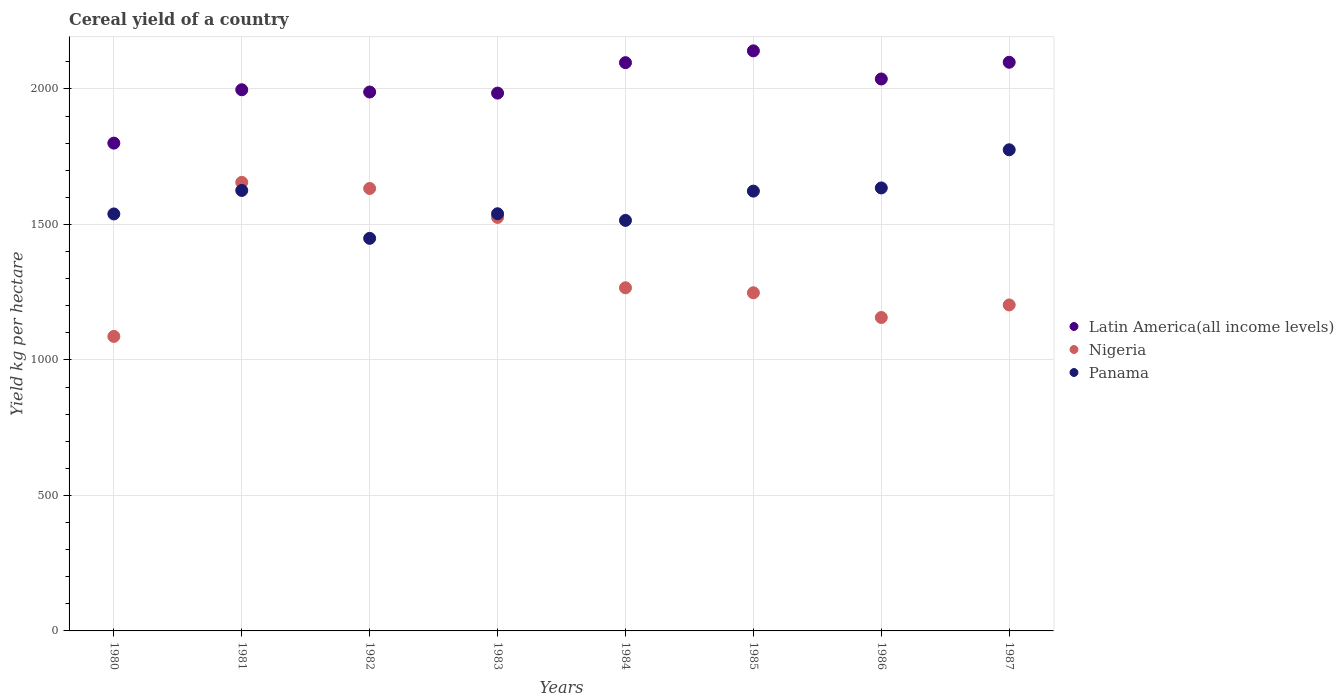Is the number of dotlines equal to the number of legend labels?
Ensure brevity in your answer.  Yes. What is the total cereal yield in Panama in 1983?
Your answer should be very brief. 1539.59. Across all years, what is the maximum total cereal yield in Nigeria?
Keep it short and to the point. 1655.46. Across all years, what is the minimum total cereal yield in Nigeria?
Ensure brevity in your answer.  1086.95. What is the total total cereal yield in Panama in the graph?
Provide a short and direct response. 1.27e+04. What is the difference between the total cereal yield in Latin America(all income levels) in 1982 and that in 1987?
Your answer should be compact. -109.78. What is the difference between the total cereal yield in Latin America(all income levels) in 1984 and the total cereal yield in Nigeria in 1985?
Offer a terse response. 849.26. What is the average total cereal yield in Panama per year?
Make the answer very short. 1587.7. In the year 1982, what is the difference between the total cereal yield in Latin America(all income levels) and total cereal yield in Nigeria?
Your response must be concise. 356. What is the ratio of the total cereal yield in Panama in 1983 to that in 1985?
Keep it short and to the point. 0.95. Is the difference between the total cereal yield in Latin America(all income levels) in 1983 and 1987 greater than the difference between the total cereal yield in Nigeria in 1983 and 1987?
Your response must be concise. No. What is the difference between the highest and the second highest total cereal yield in Panama?
Make the answer very short. 140.84. What is the difference between the highest and the lowest total cereal yield in Latin America(all income levels)?
Provide a short and direct response. 340.54. In how many years, is the total cereal yield in Panama greater than the average total cereal yield in Panama taken over all years?
Make the answer very short. 4. Is the sum of the total cereal yield in Nigeria in 1985 and 1987 greater than the maximum total cereal yield in Latin America(all income levels) across all years?
Ensure brevity in your answer.  Yes. Is it the case that in every year, the sum of the total cereal yield in Nigeria and total cereal yield in Latin America(all income levels)  is greater than the total cereal yield in Panama?
Your answer should be very brief. Yes. Is the total cereal yield in Panama strictly greater than the total cereal yield in Nigeria over the years?
Keep it short and to the point. No. Is the total cereal yield in Nigeria strictly less than the total cereal yield in Panama over the years?
Ensure brevity in your answer.  No. How many dotlines are there?
Offer a very short reply. 3. Where does the legend appear in the graph?
Give a very brief answer. Center right. How are the legend labels stacked?
Your response must be concise. Vertical. What is the title of the graph?
Ensure brevity in your answer.  Cereal yield of a country. What is the label or title of the Y-axis?
Offer a terse response. Yield kg per hectare. What is the Yield kg per hectare in Latin America(all income levels) in 1980?
Provide a short and direct response. 1800.24. What is the Yield kg per hectare in Nigeria in 1980?
Ensure brevity in your answer.  1086.95. What is the Yield kg per hectare in Panama in 1980?
Your answer should be compact. 1538.86. What is the Yield kg per hectare of Latin America(all income levels) in 1981?
Provide a succinct answer. 1997.19. What is the Yield kg per hectare in Nigeria in 1981?
Offer a terse response. 1655.46. What is the Yield kg per hectare in Panama in 1981?
Keep it short and to the point. 1625.58. What is the Yield kg per hectare in Latin America(all income levels) in 1982?
Offer a very short reply. 1988.86. What is the Yield kg per hectare of Nigeria in 1982?
Your answer should be compact. 1632.86. What is the Yield kg per hectare in Panama in 1982?
Give a very brief answer. 1448.84. What is the Yield kg per hectare in Latin America(all income levels) in 1983?
Your answer should be compact. 1984.83. What is the Yield kg per hectare in Nigeria in 1983?
Provide a short and direct response. 1526.02. What is the Yield kg per hectare in Panama in 1983?
Your answer should be very brief. 1539.59. What is the Yield kg per hectare of Latin America(all income levels) in 1984?
Your response must be concise. 2097.18. What is the Yield kg per hectare of Nigeria in 1984?
Provide a short and direct response. 1266.34. What is the Yield kg per hectare of Panama in 1984?
Keep it short and to the point. 1515.07. What is the Yield kg per hectare of Latin America(all income levels) in 1985?
Your response must be concise. 2140.78. What is the Yield kg per hectare of Nigeria in 1985?
Ensure brevity in your answer.  1247.93. What is the Yield kg per hectare of Panama in 1985?
Provide a succinct answer. 1623.14. What is the Yield kg per hectare in Latin America(all income levels) in 1986?
Offer a terse response. 2036.96. What is the Yield kg per hectare of Nigeria in 1986?
Provide a short and direct response. 1156.71. What is the Yield kg per hectare of Panama in 1986?
Offer a terse response. 1634.85. What is the Yield kg per hectare in Latin America(all income levels) in 1987?
Provide a short and direct response. 2098.64. What is the Yield kg per hectare in Nigeria in 1987?
Provide a succinct answer. 1203.01. What is the Yield kg per hectare in Panama in 1987?
Offer a very short reply. 1775.69. Across all years, what is the maximum Yield kg per hectare of Latin America(all income levels)?
Give a very brief answer. 2140.78. Across all years, what is the maximum Yield kg per hectare in Nigeria?
Your answer should be very brief. 1655.46. Across all years, what is the maximum Yield kg per hectare in Panama?
Provide a succinct answer. 1775.69. Across all years, what is the minimum Yield kg per hectare in Latin America(all income levels)?
Give a very brief answer. 1800.24. Across all years, what is the minimum Yield kg per hectare in Nigeria?
Keep it short and to the point. 1086.95. Across all years, what is the minimum Yield kg per hectare in Panama?
Keep it short and to the point. 1448.84. What is the total Yield kg per hectare in Latin America(all income levels) in the graph?
Ensure brevity in your answer.  1.61e+04. What is the total Yield kg per hectare of Nigeria in the graph?
Keep it short and to the point. 1.08e+04. What is the total Yield kg per hectare of Panama in the graph?
Offer a terse response. 1.27e+04. What is the difference between the Yield kg per hectare of Latin America(all income levels) in 1980 and that in 1981?
Your answer should be compact. -196.95. What is the difference between the Yield kg per hectare of Nigeria in 1980 and that in 1981?
Make the answer very short. -568.51. What is the difference between the Yield kg per hectare in Panama in 1980 and that in 1981?
Make the answer very short. -86.72. What is the difference between the Yield kg per hectare in Latin America(all income levels) in 1980 and that in 1982?
Your answer should be compact. -188.62. What is the difference between the Yield kg per hectare of Nigeria in 1980 and that in 1982?
Provide a succinct answer. -545.91. What is the difference between the Yield kg per hectare of Panama in 1980 and that in 1982?
Ensure brevity in your answer.  90.03. What is the difference between the Yield kg per hectare in Latin America(all income levels) in 1980 and that in 1983?
Provide a short and direct response. -184.6. What is the difference between the Yield kg per hectare in Nigeria in 1980 and that in 1983?
Your response must be concise. -439.07. What is the difference between the Yield kg per hectare of Panama in 1980 and that in 1983?
Give a very brief answer. -0.73. What is the difference between the Yield kg per hectare in Latin America(all income levels) in 1980 and that in 1984?
Provide a short and direct response. -296.95. What is the difference between the Yield kg per hectare in Nigeria in 1980 and that in 1984?
Provide a succinct answer. -179.39. What is the difference between the Yield kg per hectare of Panama in 1980 and that in 1984?
Offer a very short reply. 23.79. What is the difference between the Yield kg per hectare in Latin America(all income levels) in 1980 and that in 1985?
Give a very brief answer. -340.54. What is the difference between the Yield kg per hectare in Nigeria in 1980 and that in 1985?
Your answer should be very brief. -160.98. What is the difference between the Yield kg per hectare in Panama in 1980 and that in 1985?
Your answer should be compact. -84.28. What is the difference between the Yield kg per hectare in Latin America(all income levels) in 1980 and that in 1986?
Make the answer very short. -236.73. What is the difference between the Yield kg per hectare in Nigeria in 1980 and that in 1986?
Ensure brevity in your answer.  -69.76. What is the difference between the Yield kg per hectare of Panama in 1980 and that in 1986?
Your answer should be compact. -95.98. What is the difference between the Yield kg per hectare of Latin America(all income levels) in 1980 and that in 1987?
Provide a short and direct response. -298.4. What is the difference between the Yield kg per hectare of Nigeria in 1980 and that in 1987?
Offer a terse response. -116.06. What is the difference between the Yield kg per hectare in Panama in 1980 and that in 1987?
Your response must be concise. -236.83. What is the difference between the Yield kg per hectare of Latin America(all income levels) in 1981 and that in 1982?
Your answer should be compact. 8.34. What is the difference between the Yield kg per hectare in Nigeria in 1981 and that in 1982?
Ensure brevity in your answer.  22.61. What is the difference between the Yield kg per hectare of Panama in 1981 and that in 1982?
Offer a very short reply. 176.74. What is the difference between the Yield kg per hectare of Latin America(all income levels) in 1981 and that in 1983?
Your answer should be very brief. 12.36. What is the difference between the Yield kg per hectare of Nigeria in 1981 and that in 1983?
Provide a succinct answer. 129.45. What is the difference between the Yield kg per hectare of Panama in 1981 and that in 1983?
Your answer should be very brief. 85.99. What is the difference between the Yield kg per hectare in Latin America(all income levels) in 1981 and that in 1984?
Your answer should be compact. -99.99. What is the difference between the Yield kg per hectare in Nigeria in 1981 and that in 1984?
Provide a succinct answer. 389.13. What is the difference between the Yield kg per hectare of Panama in 1981 and that in 1984?
Provide a succinct answer. 110.51. What is the difference between the Yield kg per hectare in Latin America(all income levels) in 1981 and that in 1985?
Offer a very short reply. -143.58. What is the difference between the Yield kg per hectare in Nigeria in 1981 and that in 1985?
Make the answer very short. 407.54. What is the difference between the Yield kg per hectare in Panama in 1981 and that in 1985?
Offer a very short reply. 2.44. What is the difference between the Yield kg per hectare in Latin America(all income levels) in 1981 and that in 1986?
Give a very brief answer. -39.77. What is the difference between the Yield kg per hectare of Nigeria in 1981 and that in 1986?
Ensure brevity in your answer.  498.75. What is the difference between the Yield kg per hectare of Panama in 1981 and that in 1986?
Give a very brief answer. -9.27. What is the difference between the Yield kg per hectare of Latin America(all income levels) in 1981 and that in 1987?
Offer a terse response. -101.44. What is the difference between the Yield kg per hectare in Nigeria in 1981 and that in 1987?
Keep it short and to the point. 452.45. What is the difference between the Yield kg per hectare of Panama in 1981 and that in 1987?
Offer a very short reply. -150.11. What is the difference between the Yield kg per hectare of Latin America(all income levels) in 1982 and that in 1983?
Offer a terse response. 4.02. What is the difference between the Yield kg per hectare in Nigeria in 1982 and that in 1983?
Provide a succinct answer. 106.84. What is the difference between the Yield kg per hectare of Panama in 1982 and that in 1983?
Your answer should be very brief. -90.76. What is the difference between the Yield kg per hectare of Latin America(all income levels) in 1982 and that in 1984?
Ensure brevity in your answer.  -108.33. What is the difference between the Yield kg per hectare in Nigeria in 1982 and that in 1984?
Make the answer very short. 366.52. What is the difference between the Yield kg per hectare in Panama in 1982 and that in 1984?
Ensure brevity in your answer.  -66.23. What is the difference between the Yield kg per hectare in Latin America(all income levels) in 1982 and that in 1985?
Your response must be concise. -151.92. What is the difference between the Yield kg per hectare of Nigeria in 1982 and that in 1985?
Your answer should be very brief. 384.93. What is the difference between the Yield kg per hectare of Panama in 1982 and that in 1985?
Offer a very short reply. -174.3. What is the difference between the Yield kg per hectare of Latin America(all income levels) in 1982 and that in 1986?
Offer a very short reply. -48.11. What is the difference between the Yield kg per hectare of Nigeria in 1982 and that in 1986?
Your answer should be very brief. 476.15. What is the difference between the Yield kg per hectare in Panama in 1982 and that in 1986?
Provide a short and direct response. -186.01. What is the difference between the Yield kg per hectare of Latin America(all income levels) in 1982 and that in 1987?
Ensure brevity in your answer.  -109.78. What is the difference between the Yield kg per hectare of Nigeria in 1982 and that in 1987?
Keep it short and to the point. 429.85. What is the difference between the Yield kg per hectare in Panama in 1982 and that in 1987?
Your response must be concise. -326.85. What is the difference between the Yield kg per hectare in Latin America(all income levels) in 1983 and that in 1984?
Provide a succinct answer. -112.35. What is the difference between the Yield kg per hectare of Nigeria in 1983 and that in 1984?
Your answer should be very brief. 259.68. What is the difference between the Yield kg per hectare in Panama in 1983 and that in 1984?
Make the answer very short. 24.52. What is the difference between the Yield kg per hectare of Latin America(all income levels) in 1983 and that in 1985?
Give a very brief answer. -155.94. What is the difference between the Yield kg per hectare of Nigeria in 1983 and that in 1985?
Make the answer very short. 278.09. What is the difference between the Yield kg per hectare of Panama in 1983 and that in 1985?
Your answer should be very brief. -83.55. What is the difference between the Yield kg per hectare in Latin America(all income levels) in 1983 and that in 1986?
Keep it short and to the point. -52.13. What is the difference between the Yield kg per hectare in Nigeria in 1983 and that in 1986?
Your answer should be very brief. 369.3. What is the difference between the Yield kg per hectare of Panama in 1983 and that in 1986?
Your answer should be very brief. -95.25. What is the difference between the Yield kg per hectare of Latin America(all income levels) in 1983 and that in 1987?
Provide a short and direct response. -113.8. What is the difference between the Yield kg per hectare of Nigeria in 1983 and that in 1987?
Provide a succinct answer. 323.01. What is the difference between the Yield kg per hectare in Panama in 1983 and that in 1987?
Offer a terse response. -236.09. What is the difference between the Yield kg per hectare of Latin America(all income levels) in 1984 and that in 1985?
Give a very brief answer. -43.59. What is the difference between the Yield kg per hectare in Nigeria in 1984 and that in 1985?
Give a very brief answer. 18.41. What is the difference between the Yield kg per hectare in Panama in 1984 and that in 1985?
Provide a succinct answer. -108.07. What is the difference between the Yield kg per hectare in Latin America(all income levels) in 1984 and that in 1986?
Your answer should be very brief. 60.22. What is the difference between the Yield kg per hectare of Nigeria in 1984 and that in 1986?
Your answer should be compact. 109.62. What is the difference between the Yield kg per hectare in Panama in 1984 and that in 1986?
Your answer should be very brief. -119.78. What is the difference between the Yield kg per hectare in Latin America(all income levels) in 1984 and that in 1987?
Your answer should be compact. -1.45. What is the difference between the Yield kg per hectare of Nigeria in 1984 and that in 1987?
Provide a succinct answer. 63.33. What is the difference between the Yield kg per hectare in Panama in 1984 and that in 1987?
Offer a very short reply. -260.62. What is the difference between the Yield kg per hectare of Latin America(all income levels) in 1985 and that in 1986?
Make the answer very short. 103.81. What is the difference between the Yield kg per hectare in Nigeria in 1985 and that in 1986?
Ensure brevity in your answer.  91.22. What is the difference between the Yield kg per hectare in Panama in 1985 and that in 1986?
Your response must be concise. -11.71. What is the difference between the Yield kg per hectare in Latin America(all income levels) in 1985 and that in 1987?
Keep it short and to the point. 42.14. What is the difference between the Yield kg per hectare of Nigeria in 1985 and that in 1987?
Your answer should be very brief. 44.92. What is the difference between the Yield kg per hectare of Panama in 1985 and that in 1987?
Provide a short and direct response. -152.55. What is the difference between the Yield kg per hectare in Latin America(all income levels) in 1986 and that in 1987?
Offer a terse response. -61.67. What is the difference between the Yield kg per hectare in Nigeria in 1986 and that in 1987?
Offer a terse response. -46.3. What is the difference between the Yield kg per hectare in Panama in 1986 and that in 1987?
Provide a short and direct response. -140.84. What is the difference between the Yield kg per hectare in Latin America(all income levels) in 1980 and the Yield kg per hectare in Nigeria in 1981?
Provide a short and direct response. 144.77. What is the difference between the Yield kg per hectare in Latin America(all income levels) in 1980 and the Yield kg per hectare in Panama in 1981?
Keep it short and to the point. 174.66. What is the difference between the Yield kg per hectare of Nigeria in 1980 and the Yield kg per hectare of Panama in 1981?
Your answer should be very brief. -538.63. What is the difference between the Yield kg per hectare in Latin America(all income levels) in 1980 and the Yield kg per hectare in Nigeria in 1982?
Provide a short and direct response. 167.38. What is the difference between the Yield kg per hectare of Latin America(all income levels) in 1980 and the Yield kg per hectare of Panama in 1982?
Offer a terse response. 351.4. What is the difference between the Yield kg per hectare of Nigeria in 1980 and the Yield kg per hectare of Panama in 1982?
Offer a very short reply. -361.88. What is the difference between the Yield kg per hectare in Latin America(all income levels) in 1980 and the Yield kg per hectare in Nigeria in 1983?
Your answer should be compact. 274.22. What is the difference between the Yield kg per hectare of Latin America(all income levels) in 1980 and the Yield kg per hectare of Panama in 1983?
Offer a very short reply. 260.64. What is the difference between the Yield kg per hectare in Nigeria in 1980 and the Yield kg per hectare in Panama in 1983?
Offer a terse response. -452.64. What is the difference between the Yield kg per hectare of Latin America(all income levels) in 1980 and the Yield kg per hectare of Nigeria in 1984?
Make the answer very short. 533.9. What is the difference between the Yield kg per hectare in Latin America(all income levels) in 1980 and the Yield kg per hectare in Panama in 1984?
Ensure brevity in your answer.  285.17. What is the difference between the Yield kg per hectare in Nigeria in 1980 and the Yield kg per hectare in Panama in 1984?
Keep it short and to the point. -428.12. What is the difference between the Yield kg per hectare in Latin America(all income levels) in 1980 and the Yield kg per hectare in Nigeria in 1985?
Ensure brevity in your answer.  552.31. What is the difference between the Yield kg per hectare in Latin America(all income levels) in 1980 and the Yield kg per hectare in Panama in 1985?
Your answer should be compact. 177.1. What is the difference between the Yield kg per hectare in Nigeria in 1980 and the Yield kg per hectare in Panama in 1985?
Provide a short and direct response. -536.19. What is the difference between the Yield kg per hectare in Latin America(all income levels) in 1980 and the Yield kg per hectare in Nigeria in 1986?
Offer a very short reply. 643.52. What is the difference between the Yield kg per hectare of Latin America(all income levels) in 1980 and the Yield kg per hectare of Panama in 1986?
Provide a short and direct response. 165.39. What is the difference between the Yield kg per hectare of Nigeria in 1980 and the Yield kg per hectare of Panama in 1986?
Give a very brief answer. -547.9. What is the difference between the Yield kg per hectare of Latin America(all income levels) in 1980 and the Yield kg per hectare of Nigeria in 1987?
Give a very brief answer. 597.23. What is the difference between the Yield kg per hectare in Latin America(all income levels) in 1980 and the Yield kg per hectare in Panama in 1987?
Your answer should be compact. 24.55. What is the difference between the Yield kg per hectare of Nigeria in 1980 and the Yield kg per hectare of Panama in 1987?
Provide a short and direct response. -688.74. What is the difference between the Yield kg per hectare in Latin America(all income levels) in 1981 and the Yield kg per hectare in Nigeria in 1982?
Provide a succinct answer. 364.33. What is the difference between the Yield kg per hectare of Latin America(all income levels) in 1981 and the Yield kg per hectare of Panama in 1982?
Your answer should be compact. 548.36. What is the difference between the Yield kg per hectare of Nigeria in 1981 and the Yield kg per hectare of Panama in 1982?
Keep it short and to the point. 206.63. What is the difference between the Yield kg per hectare in Latin America(all income levels) in 1981 and the Yield kg per hectare in Nigeria in 1983?
Your answer should be very brief. 471.18. What is the difference between the Yield kg per hectare of Latin America(all income levels) in 1981 and the Yield kg per hectare of Panama in 1983?
Your answer should be very brief. 457.6. What is the difference between the Yield kg per hectare of Nigeria in 1981 and the Yield kg per hectare of Panama in 1983?
Ensure brevity in your answer.  115.87. What is the difference between the Yield kg per hectare in Latin America(all income levels) in 1981 and the Yield kg per hectare in Nigeria in 1984?
Provide a succinct answer. 730.85. What is the difference between the Yield kg per hectare of Latin America(all income levels) in 1981 and the Yield kg per hectare of Panama in 1984?
Offer a very short reply. 482.12. What is the difference between the Yield kg per hectare in Nigeria in 1981 and the Yield kg per hectare in Panama in 1984?
Your answer should be very brief. 140.4. What is the difference between the Yield kg per hectare of Latin America(all income levels) in 1981 and the Yield kg per hectare of Nigeria in 1985?
Give a very brief answer. 749.26. What is the difference between the Yield kg per hectare of Latin America(all income levels) in 1981 and the Yield kg per hectare of Panama in 1985?
Provide a short and direct response. 374.05. What is the difference between the Yield kg per hectare of Nigeria in 1981 and the Yield kg per hectare of Panama in 1985?
Your answer should be compact. 32.33. What is the difference between the Yield kg per hectare in Latin America(all income levels) in 1981 and the Yield kg per hectare in Nigeria in 1986?
Make the answer very short. 840.48. What is the difference between the Yield kg per hectare in Latin America(all income levels) in 1981 and the Yield kg per hectare in Panama in 1986?
Your response must be concise. 362.35. What is the difference between the Yield kg per hectare in Nigeria in 1981 and the Yield kg per hectare in Panama in 1986?
Your response must be concise. 20.62. What is the difference between the Yield kg per hectare in Latin America(all income levels) in 1981 and the Yield kg per hectare in Nigeria in 1987?
Keep it short and to the point. 794.18. What is the difference between the Yield kg per hectare of Latin America(all income levels) in 1981 and the Yield kg per hectare of Panama in 1987?
Your answer should be very brief. 221.5. What is the difference between the Yield kg per hectare in Nigeria in 1981 and the Yield kg per hectare in Panama in 1987?
Your answer should be compact. -120.22. What is the difference between the Yield kg per hectare in Latin America(all income levels) in 1982 and the Yield kg per hectare in Nigeria in 1983?
Make the answer very short. 462.84. What is the difference between the Yield kg per hectare of Latin America(all income levels) in 1982 and the Yield kg per hectare of Panama in 1983?
Provide a short and direct response. 449.26. What is the difference between the Yield kg per hectare in Nigeria in 1982 and the Yield kg per hectare in Panama in 1983?
Offer a terse response. 93.27. What is the difference between the Yield kg per hectare in Latin America(all income levels) in 1982 and the Yield kg per hectare in Nigeria in 1984?
Provide a succinct answer. 722.52. What is the difference between the Yield kg per hectare in Latin America(all income levels) in 1982 and the Yield kg per hectare in Panama in 1984?
Provide a succinct answer. 473.79. What is the difference between the Yield kg per hectare in Nigeria in 1982 and the Yield kg per hectare in Panama in 1984?
Your answer should be very brief. 117.79. What is the difference between the Yield kg per hectare of Latin America(all income levels) in 1982 and the Yield kg per hectare of Nigeria in 1985?
Offer a very short reply. 740.93. What is the difference between the Yield kg per hectare in Latin America(all income levels) in 1982 and the Yield kg per hectare in Panama in 1985?
Offer a very short reply. 365.72. What is the difference between the Yield kg per hectare in Nigeria in 1982 and the Yield kg per hectare in Panama in 1985?
Your answer should be very brief. 9.72. What is the difference between the Yield kg per hectare in Latin America(all income levels) in 1982 and the Yield kg per hectare in Nigeria in 1986?
Provide a succinct answer. 832.14. What is the difference between the Yield kg per hectare of Latin America(all income levels) in 1982 and the Yield kg per hectare of Panama in 1986?
Your response must be concise. 354.01. What is the difference between the Yield kg per hectare of Nigeria in 1982 and the Yield kg per hectare of Panama in 1986?
Offer a very short reply. -1.99. What is the difference between the Yield kg per hectare in Latin America(all income levels) in 1982 and the Yield kg per hectare in Nigeria in 1987?
Your response must be concise. 785.85. What is the difference between the Yield kg per hectare of Latin America(all income levels) in 1982 and the Yield kg per hectare of Panama in 1987?
Your response must be concise. 213.17. What is the difference between the Yield kg per hectare in Nigeria in 1982 and the Yield kg per hectare in Panama in 1987?
Your answer should be compact. -142.83. What is the difference between the Yield kg per hectare in Latin America(all income levels) in 1983 and the Yield kg per hectare in Nigeria in 1984?
Your answer should be very brief. 718.5. What is the difference between the Yield kg per hectare of Latin America(all income levels) in 1983 and the Yield kg per hectare of Panama in 1984?
Make the answer very short. 469.77. What is the difference between the Yield kg per hectare in Nigeria in 1983 and the Yield kg per hectare in Panama in 1984?
Your response must be concise. 10.95. What is the difference between the Yield kg per hectare in Latin America(all income levels) in 1983 and the Yield kg per hectare in Nigeria in 1985?
Keep it short and to the point. 736.91. What is the difference between the Yield kg per hectare of Latin America(all income levels) in 1983 and the Yield kg per hectare of Panama in 1985?
Give a very brief answer. 361.7. What is the difference between the Yield kg per hectare of Nigeria in 1983 and the Yield kg per hectare of Panama in 1985?
Keep it short and to the point. -97.12. What is the difference between the Yield kg per hectare of Latin America(all income levels) in 1983 and the Yield kg per hectare of Nigeria in 1986?
Your response must be concise. 828.12. What is the difference between the Yield kg per hectare of Latin America(all income levels) in 1983 and the Yield kg per hectare of Panama in 1986?
Offer a very short reply. 349.99. What is the difference between the Yield kg per hectare of Nigeria in 1983 and the Yield kg per hectare of Panama in 1986?
Offer a terse response. -108.83. What is the difference between the Yield kg per hectare of Latin America(all income levels) in 1983 and the Yield kg per hectare of Nigeria in 1987?
Make the answer very short. 781.83. What is the difference between the Yield kg per hectare of Latin America(all income levels) in 1983 and the Yield kg per hectare of Panama in 1987?
Offer a terse response. 209.15. What is the difference between the Yield kg per hectare of Nigeria in 1983 and the Yield kg per hectare of Panama in 1987?
Provide a short and direct response. -249.67. What is the difference between the Yield kg per hectare in Latin America(all income levels) in 1984 and the Yield kg per hectare in Nigeria in 1985?
Offer a terse response. 849.26. What is the difference between the Yield kg per hectare of Latin America(all income levels) in 1984 and the Yield kg per hectare of Panama in 1985?
Your response must be concise. 474.05. What is the difference between the Yield kg per hectare in Nigeria in 1984 and the Yield kg per hectare in Panama in 1985?
Offer a very short reply. -356.8. What is the difference between the Yield kg per hectare in Latin America(all income levels) in 1984 and the Yield kg per hectare in Nigeria in 1986?
Your response must be concise. 940.47. What is the difference between the Yield kg per hectare of Latin America(all income levels) in 1984 and the Yield kg per hectare of Panama in 1986?
Offer a very short reply. 462.34. What is the difference between the Yield kg per hectare in Nigeria in 1984 and the Yield kg per hectare in Panama in 1986?
Your answer should be very brief. -368.51. What is the difference between the Yield kg per hectare in Latin America(all income levels) in 1984 and the Yield kg per hectare in Nigeria in 1987?
Keep it short and to the point. 894.18. What is the difference between the Yield kg per hectare in Latin America(all income levels) in 1984 and the Yield kg per hectare in Panama in 1987?
Keep it short and to the point. 321.5. What is the difference between the Yield kg per hectare of Nigeria in 1984 and the Yield kg per hectare of Panama in 1987?
Provide a succinct answer. -509.35. What is the difference between the Yield kg per hectare in Latin America(all income levels) in 1985 and the Yield kg per hectare in Nigeria in 1986?
Your answer should be compact. 984.06. What is the difference between the Yield kg per hectare in Latin America(all income levels) in 1985 and the Yield kg per hectare in Panama in 1986?
Offer a very short reply. 505.93. What is the difference between the Yield kg per hectare in Nigeria in 1985 and the Yield kg per hectare in Panama in 1986?
Your response must be concise. -386.92. What is the difference between the Yield kg per hectare in Latin America(all income levels) in 1985 and the Yield kg per hectare in Nigeria in 1987?
Make the answer very short. 937.77. What is the difference between the Yield kg per hectare in Latin America(all income levels) in 1985 and the Yield kg per hectare in Panama in 1987?
Provide a short and direct response. 365.09. What is the difference between the Yield kg per hectare of Nigeria in 1985 and the Yield kg per hectare of Panama in 1987?
Provide a succinct answer. -527.76. What is the difference between the Yield kg per hectare in Latin America(all income levels) in 1986 and the Yield kg per hectare in Nigeria in 1987?
Give a very brief answer. 833.95. What is the difference between the Yield kg per hectare in Latin America(all income levels) in 1986 and the Yield kg per hectare in Panama in 1987?
Your answer should be very brief. 261.28. What is the difference between the Yield kg per hectare in Nigeria in 1986 and the Yield kg per hectare in Panama in 1987?
Your answer should be very brief. -618.98. What is the average Yield kg per hectare of Latin America(all income levels) per year?
Offer a terse response. 2018.08. What is the average Yield kg per hectare in Nigeria per year?
Give a very brief answer. 1346.91. What is the average Yield kg per hectare of Panama per year?
Your response must be concise. 1587.7. In the year 1980, what is the difference between the Yield kg per hectare of Latin America(all income levels) and Yield kg per hectare of Nigeria?
Offer a very short reply. 713.29. In the year 1980, what is the difference between the Yield kg per hectare in Latin America(all income levels) and Yield kg per hectare in Panama?
Your response must be concise. 261.38. In the year 1980, what is the difference between the Yield kg per hectare of Nigeria and Yield kg per hectare of Panama?
Give a very brief answer. -451.91. In the year 1981, what is the difference between the Yield kg per hectare in Latin America(all income levels) and Yield kg per hectare in Nigeria?
Your answer should be compact. 341.73. In the year 1981, what is the difference between the Yield kg per hectare in Latin America(all income levels) and Yield kg per hectare in Panama?
Provide a short and direct response. 371.61. In the year 1981, what is the difference between the Yield kg per hectare in Nigeria and Yield kg per hectare in Panama?
Ensure brevity in your answer.  29.89. In the year 1982, what is the difference between the Yield kg per hectare in Latin America(all income levels) and Yield kg per hectare in Nigeria?
Your answer should be compact. 356. In the year 1982, what is the difference between the Yield kg per hectare in Latin America(all income levels) and Yield kg per hectare in Panama?
Your answer should be very brief. 540.02. In the year 1982, what is the difference between the Yield kg per hectare in Nigeria and Yield kg per hectare in Panama?
Offer a very short reply. 184.02. In the year 1983, what is the difference between the Yield kg per hectare in Latin America(all income levels) and Yield kg per hectare in Nigeria?
Your answer should be very brief. 458.82. In the year 1983, what is the difference between the Yield kg per hectare of Latin America(all income levels) and Yield kg per hectare of Panama?
Offer a very short reply. 445.24. In the year 1983, what is the difference between the Yield kg per hectare of Nigeria and Yield kg per hectare of Panama?
Provide a short and direct response. -13.58. In the year 1984, what is the difference between the Yield kg per hectare of Latin America(all income levels) and Yield kg per hectare of Nigeria?
Your answer should be compact. 830.85. In the year 1984, what is the difference between the Yield kg per hectare of Latin America(all income levels) and Yield kg per hectare of Panama?
Offer a very short reply. 582.12. In the year 1984, what is the difference between the Yield kg per hectare in Nigeria and Yield kg per hectare in Panama?
Provide a short and direct response. -248.73. In the year 1985, what is the difference between the Yield kg per hectare of Latin America(all income levels) and Yield kg per hectare of Nigeria?
Offer a very short reply. 892.85. In the year 1985, what is the difference between the Yield kg per hectare in Latin America(all income levels) and Yield kg per hectare in Panama?
Provide a short and direct response. 517.64. In the year 1985, what is the difference between the Yield kg per hectare in Nigeria and Yield kg per hectare in Panama?
Offer a terse response. -375.21. In the year 1986, what is the difference between the Yield kg per hectare of Latin America(all income levels) and Yield kg per hectare of Nigeria?
Make the answer very short. 880.25. In the year 1986, what is the difference between the Yield kg per hectare of Latin America(all income levels) and Yield kg per hectare of Panama?
Your answer should be compact. 402.12. In the year 1986, what is the difference between the Yield kg per hectare in Nigeria and Yield kg per hectare in Panama?
Your answer should be very brief. -478.13. In the year 1987, what is the difference between the Yield kg per hectare in Latin America(all income levels) and Yield kg per hectare in Nigeria?
Keep it short and to the point. 895.63. In the year 1987, what is the difference between the Yield kg per hectare of Latin America(all income levels) and Yield kg per hectare of Panama?
Your response must be concise. 322.95. In the year 1987, what is the difference between the Yield kg per hectare of Nigeria and Yield kg per hectare of Panama?
Your response must be concise. -572.68. What is the ratio of the Yield kg per hectare of Latin America(all income levels) in 1980 to that in 1981?
Give a very brief answer. 0.9. What is the ratio of the Yield kg per hectare in Nigeria in 1980 to that in 1981?
Make the answer very short. 0.66. What is the ratio of the Yield kg per hectare in Panama in 1980 to that in 1981?
Your response must be concise. 0.95. What is the ratio of the Yield kg per hectare in Latin America(all income levels) in 1980 to that in 1982?
Keep it short and to the point. 0.91. What is the ratio of the Yield kg per hectare in Nigeria in 1980 to that in 1982?
Provide a short and direct response. 0.67. What is the ratio of the Yield kg per hectare of Panama in 1980 to that in 1982?
Keep it short and to the point. 1.06. What is the ratio of the Yield kg per hectare in Latin America(all income levels) in 1980 to that in 1983?
Your answer should be very brief. 0.91. What is the ratio of the Yield kg per hectare of Nigeria in 1980 to that in 1983?
Your answer should be compact. 0.71. What is the ratio of the Yield kg per hectare of Latin America(all income levels) in 1980 to that in 1984?
Your answer should be compact. 0.86. What is the ratio of the Yield kg per hectare in Nigeria in 1980 to that in 1984?
Ensure brevity in your answer.  0.86. What is the ratio of the Yield kg per hectare in Panama in 1980 to that in 1984?
Offer a terse response. 1.02. What is the ratio of the Yield kg per hectare in Latin America(all income levels) in 1980 to that in 1985?
Your answer should be compact. 0.84. What is the ratio of the Yield kg per hectare in Nigeria in 1980 to that in 1985?
Offer a very short reply. 0.87. What is the ratio of the Yield kg per hectare of Panama in 1980 to that in 1985?
Provide a short and direct response. 0.95. What is the ratio of the Yield kg per hectare in Latin America(all income levels) in 1980 to that in 1986?
Provide a short and direct response. 0.88. What is the ratio of the Yield kg per hectare of Nigeria in 1980 to that in 1986?
Make the answer very short. 0.94. What is the ratio of the Yield kg per hectare of Panama in 1980 to that in 1986?
Provide a short and direct response. 0.94. What is the ratio of the Yield kg per hectare of Latin America(all income levels) in 1980 to that in 1987?
Your answer should be very brief. 0.86. What is the ratio of the Yield kg per hectare in Nigeria in 1980 to that in 1987?
Give a very brief answer. 0.9. What is the ratio of the Yield kg per hectare in Panama in 1980 to that in 1987?
Keep it short and to the point. 0.87. What is the ratio of the Yield kg per hectare in Nigeria in 1981 to that in 1982?
Offer a very short reply. 1.01. What is the ratio of the Yield kg per hectare in Panama in 1981 to that in 1982?
Give a very brief answer. 1.12. What is the ratio of the Yield kg per hectare of Nigeria in 1981 to that in 1983?
Provide a short and direct response. 1.08. What is the ratio of the Yield kg per hectare in Panama in 1981 to that in 1983?
Provide a succinct answer. 1.06. What is the ratio of the Yield kg per hectare of Latin America(all income levels) in 1981 to that in 1984?
Your response must be concise. 0.95. What is the ratio of the Yield kg per hectare of Nigeria in 1981 to that in 1984?
Make the answer very short. 1.31. What is the ratio of the Yield kg per hectare of Panama in 1981 to that in 1984?
Provide a short and direct response. 1.07. What is the ratio of the Yield kg per hectare of Latin America(all income levels) in 1981 to that in 1985?
Provide a short and direct response. 0.93. What is the ratio of the Yield kg per hectare of Nigeria in 1981 to that in 1985?
Offer a very short reply. 1.33. What is the ratio of the Yield kg per hectare of Panama in 1981 to that in 1985?
Offer a terse response. 1. What is the ratio of the Yield kg per hectare in Latin America(all income levels) in 1981 to that in 1986?
Ensure brevity in your answer.  0.98. What is the ratio of the Yield kg per hectare in Nigeria in 1981 to that in 1986?
Provide a succinct answer. 1.43. What is the ratio of the Yield kg per hectare of Latin America(all income levels) in 1981 to that in 1987?
Provide a succinct answer. 0.95. What is the ratio of the Yield kg per hectare of Nigeria in 1981 to that in 1987?
Offer a terse response. 1.38. What is the ratio of the Yield kg per hectare in Panama in 1981 to that in 1987?
Your answer should be compact. 0.92. What is the ratio of the Yield kg per hectare in Nigeria in 1982 to that in 1983?
Offer a very short reply. 1.07. What is the ratio of the Yield kg per hectare of Panama in 1982 to that in 1983?
Your answer should be compact. 0.94. What is the ratio of the Yield kg per hectare in Latin America(all income levels) in 1982 to that in 1984?
Make the answer very short. 0.95. What is the ratio of the Yield kg per hectare in Nigeria in 1982 to that in 1984?
Your response must be concise. 1.29. What is the ratio of the Yield kg per hectare in Panama in 1982 to that in 1984?
Offer a terse response. 0.96. What is the ratio of the Yield kg per hectare of Latin America(all income levels) in 1982 to that in 1985?
Your response must be concise. 0.93. What is the ratio of the Yield kg per hectare in Nigeria in 1982 to that in 1985?
Offer a terse response. 1.31. What is the ratio of the Yield kg per hectare of Panama in 1982 to that in 1985?
Offer a terse response. 0.89. What is the ratio of the Yield kg per hectare in Latin America(all income levels) in 1982 to that in 1986?
Your answer should be compact. 0.98. What is the ratio of the Yield kg per hectare of Nigeria in 1982 to that in 1986?
Your response must be concise. 1.41. What is the ratio of the Yield kg per hectare of Panama in 1982 to that in 1986?
Give a very brief answer. 0.89. What is the ratio of the Yield kg per hectare in Latin America(all income levels) in 1982 to that in 1987?
Provide a short and direct response. 0.95. What is the ratio of the Yield kg per hectare in Nigeria in 1982 to that in 1987?
Provide a short and direct response. 1.36. What is the ratio of the Yield kg per hectare in Panama in 1982 to that in 1987?
Provide a short and direct response. 0.82. What is the ratio of the Yield kg per hectare in Latin America(all income levels) in 1983 to that in 1984?
Keep it short and to the point. 0.95. What is the ratio of the Yield kg per hectare in Nigeria in 1983 to that in 1984?
Provide a short and direct response. 1.21. What is the ratio of the Yield kg per hectare of Panama in 1983 to that in 1984?
Ensure brevity in your answer.  1.02. What is the ratio of the Yield kg per hectare in Latin America(all income levels) in 1983 to that in 1985?
Make the answer very short. 0.93. What is the ratio of the Yield kg per hectare in Nigeria in 1983 to that in 1985?
Keep it short and to the point. 1.22. What is the ratio of the Yield kg per hectare in Panama in 1983 to that in 1985?
Ensure brevity in your answer.  0.95. What is the ratio of the Yield kg per hectare of Latin America(all income levels) in 1983 to that in 1986?
Make the answer very short. 0.97. What is the ratio of the Yield kg per hectare of Nigeria in 1983 to that in 1986?
Offer a terse response. 1.32. What is the ratio of the Yield kg per hectare in Panama in 1983 to that in 1986?
Provide a succinct answer. 0.94. What is the ratio of the Yield kg per hectare in Latin America(all income levels) in 1983 to that in 1987?
Provide a succinct answer. 0.95. What is the ratio of the Yield kg per hectare in Nigeria in 1983 to that in 1987?
Your answer should be very brief. 1.27. What is the ratio of the Yield kg per hectare of Panama in 1983 to that in 1987?
Your answer should be compact. 0.87. What is the ratio of the Yield kg per hectare in Latin America(all income levels) in 1984 to that in 1985?
Your answer should be compact. 0.98. What is the ratio of the Yield kg per hectare in Nigeria in 1984 to that in 1985?
Ensure brevity in your answer.  1.01. What is the ratio of the Yield kg per hectare of Panama in 1984 to that in 1985?
Provide a succinct answer. 0.93. What is the ratio of the Yield kg per hectare in Latin America(all income levels) in 1984 to that in 1986?
Give a very brief answer. 1.03. What is the ratio of the Yield kg per hectare in Nigeria in 1984 to that in 1986?
Offer a terse response. 1.09. What is the ratio of the Yield kg per hectare in Panama in 1984 to that in 1986?
Ensure brevity in your answer.  0.93. What is the ratio of the Yield kg per hectare of Latin America(all income levels) in 1984 to that in 1987?
Ensure brevity in your answer.  1. What is the ratio of the Yield kg per hectare of Nigeria in 1984 to that in 1987?
Your answer should be very brief. 1.05. What is the ratio of the Yield kg per hectare in Panama in 1984 to that in 1987?
Offer a terse response. 0.85. What is the ratio of the Yield kg per hectare in Latin America(all income levels) in 1985 to that in 1986?
Your answer should be compact. 1.05. What is the ratio of the Yield kg per hectare of Nigeria in 1985 to that in 1986?
Give a very brief answer. 1.08. What is the ratio of the Yield kg per hectare of Latin America(all income levels) in 1985 to that in 1987?
Offer a very short reply. 1.02. What is the ratio of the Yield kg per hectare of Nigeria in 1985 to that in 1987?
Ensure brevity in your answer.  1.04. What is the ratio of the Yield kg per hectare of Panama in 1985 to that in 1987?
Provide a short and direct response. 0.91. What is the ratio of the Yield kg per hectare in Latin America(all income levels) in 1986 to that in 1987?
Provide a short and direct response. 0.97. What is the ratio of the Yield kg per hectare in Nigeria in 1986 to that in 1987?
Your response must be concise. 0.96. What is the ratio of the Yield kg per hectare of Panama in 1986 to that in 1987?
Keep it short and to the point. 0.92. What is the difference between the highest and the second highest Yield kg per hectare of Latin America(all income levels)?
Offer a terse response. 42.14. What is the difference between the highest and the second highest Yield kg per hectare of Nigeria?
Give a very brief answer. 22.61. What is the difference between the highest and the second highest Yield kg per hectare of Panama?
Your response must be concise. 140.84. What is the difference between the highest and the lowest Yield kg per hectare in Latin America(all income levels)?
Provide a short and direct response. 340.54. What is the difference between the highest and the lowest Yield kg per hectare of Nigeria?
Your response must be concise. 568.51. What is the difference between the highest and the lowest Yield kg per hectare of Panama?
Provide a succinct answer. 326.85. 